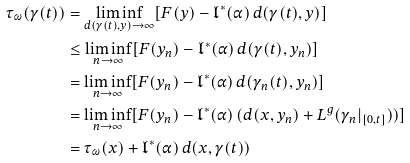Convert formula to latex. <formula><loc_0><loc_0><loc_500><loc_500>\tau _ { \omega } ( \gamma ( t ) ) & = \liminf _ { d ( \gamma ( t ) , y ) \to \infty } [ F ( y ) - \mathfrak { l } ^ { \ast } ( \alpha ) \, d ( \gamma ( t ) , y ) ] \\ & \leq \liminf _ { n \to \infty } [ F ( y _ { n } ) - \mathfrak { l } ^ { \ast } ( \alpha ) \, d ( \gamma ( t ) , y _ { n } ) ] \\ & = \liminf _ { n \to \infty } [ F ( y _ { n } ) - \mathfrak { l } ^ { \ast } ( \alpha ) \, d ( \gamma _ { n } ( t ) , y _ { n } ) ] \\ & = \liminf _ { n \to \infty } [ F ( y _ { n } ) - \mathfrak { l } ^ { \ast } ( \alpha ) \, ( d ( x , y _ { n } ) + L ^ { g } ( \gamma _ { n } | _ { [ 0 , t ] } ) ) ] \\ & = \tau _ { \omega } ( x ) + \mathfrak { l } ^ { \ast } ( \alpha ) \, d ( x , \gamma ( t ) )</formula> 